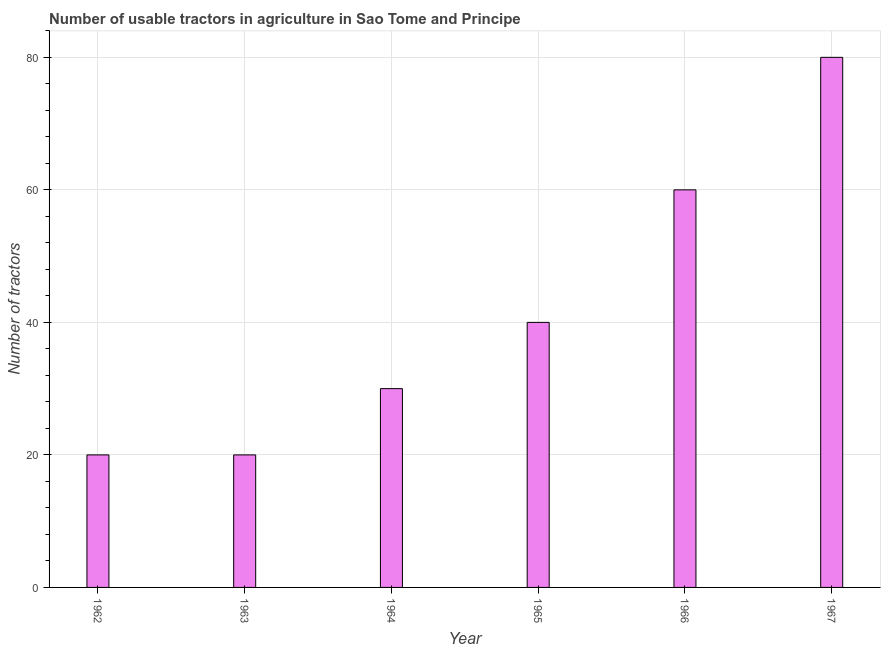Does the graph contain any zero values?
Offer a very short reply. No. What is the title of the graph?
Offer a terse response. Number of usable tractors in agriculture in Sao Tome and Principe. What is the label or title of the X-axis?
Ensure brevity in your answer.  Year. What is the label or title of the Y-axis?
Give a very brief answer. Number of tractors. In which year was the number of tractors maximum?
Provide a short and direct response. 1967. What is the sum of the number of tractors?
Make the answer very short. 250. What is the average number of tractors per year?
Provide a short and direct response. 41. In how many years, is the number of tractors greater than 68 ?
Keep it short and to the point. 1. Do a majority of the years between 1965 and 1962 (inclusive) have number of tractors greater than 52 ?
Your response must be concise. Yes. What is the ratio of the number of tractors in 1966 to that in 1967?
Give a very brief answer. 0.75. Is the difference between the number of tractors in 1962 and 1964 greater than the difference between any two years?
Give a very brief answer. No. What is the difference between the highest and the lowest number of tractors?
Ensure brevity in your answer.  60. How many bars are there?
Your answer should be compact. 6. Are all the bars in the graph horizontal?
Offer a very short reply. No. What is the difference between two consecutive major ticks on the Y-axis?
Your answer should be very brief. 20. What is the Number of tractors of 1962?
Keep it short and to the point. 20. What is the Number of tractors in 1963?
Provide a succinct answer. 20. What is the Number of tractors of 1964?
Your response must be concise. 30. What is the Number of tractors of 1966?
Provide a succinct answer. 60. What is the Number of tractors of 1967?
Ensure brevity in your answer.  80. What is the difference between the Number of tractors in 1962 and 1965?
Offer a terse response. -20. What is the difference between the Number of tractors in 1962 and 1967?
Offer a terse response. -60. What is the difference between the Number of tractors in 1963 and 1964?
Your answer should be compact. -10. What is the difference between the Number of tractors in 1963 and 1965?
Your response must be concise. -20. What is the difference between the Number of tractors in 1963 and 1966?
Keep it short and to the point. -40. What is the difference between the Number of tractors in 1963 and 1967?
Ensure brevity in your answer.  -60. What is the difference between the Number of tractors in 1964 and 1965?
Give a very brief answer. -10. What is the difference between the Number of tractors in 1964 and 1967?
Ensure brevity in your answer.  -50. What is the difference between the Number of tractors in 1965 and 1967?
Provide a short and direct response. -40. What is the difference between the Number of tractors in 1966 and 1967?
Keep it short and to the point. -20. What is the ratio of the Number of tractors in 1962 to that in 1963?
Offer a very short reply. 1. What is the ratio of the Number of tractors in 1962 to that in 1964?
Give a very brief answer. 0.67. What is the ratio of the Number of tractors in 1962 to that in 1966?
Your answer should be very brief. 0.33. What is the ratio of the Number of tractors in 1962 to that in 1967?
Give a very brief answer. 0.25. What is the ratio of the Number of tractors in 1963 to that in 1964?
Ensure brevity in your answer.  0.67. What is the ratio of the Number of tractors in 1963 to that in 1965?
Your response must be concise. 0.5. What is the ratio of the Number of tractors in 1963 to that in 1966?
Your answer should be very brief. 0.33. What is the ratio of the Number of tractors in 1964 to that in 1966?
Offer a terse response. 0.5. What is the ratio of the Number of tractors in 1964 to that in 1967?
Offer a terse response. 0.38. What is the ratio of the Number of tractors in 1965 to that in 1966?
Provide a succinct answer. 0.67. What is the ratio of the Number of tractors in 1965 to that in 1967?
Offer a terse response. 0.5. What is the ratio of the Number of tractors in 1966 to that in 1967?
Provide a succinct answer. 0.75. 